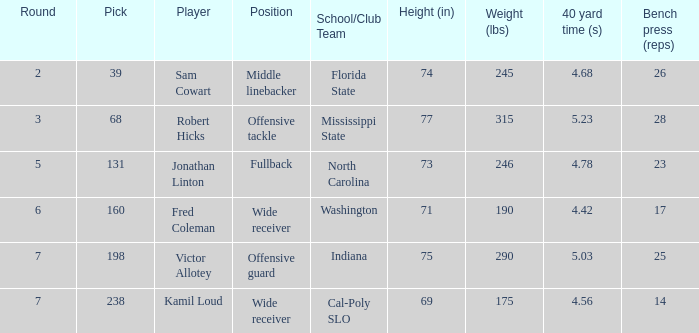Which Round has a School/Club Team of cal-poly slo, and a Pick smaller than 238? None. 